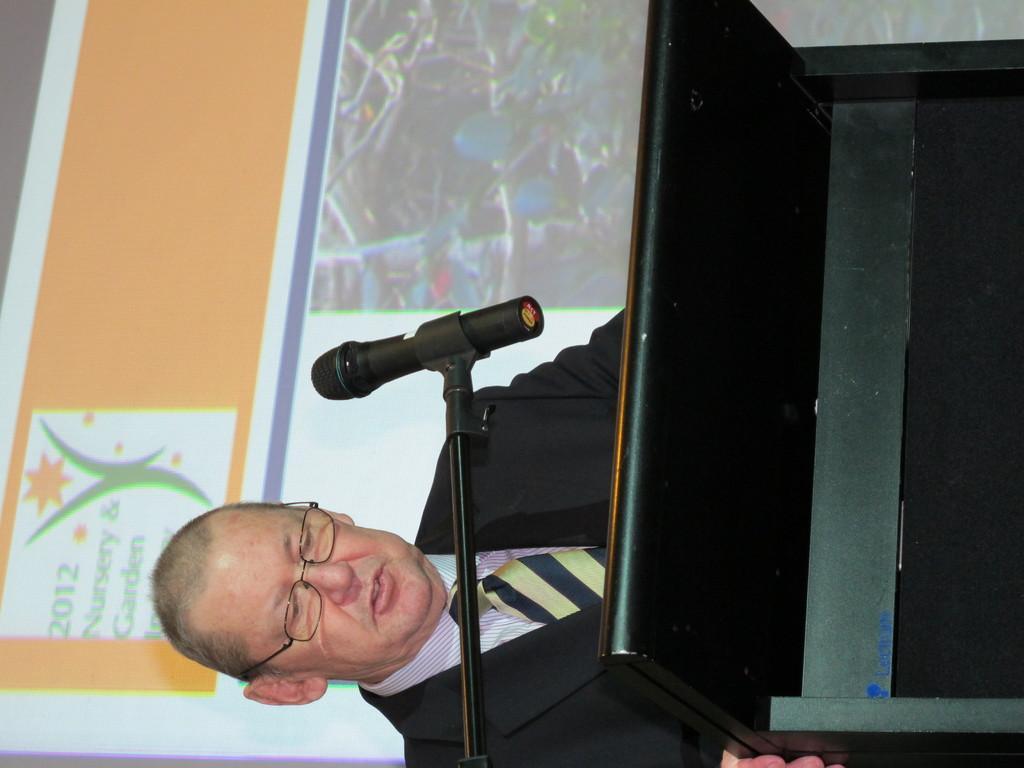Could you give a brief overview of what you see in this image? In this image there is a person standing near the podium , there is a mike with a mike stand , screen. 